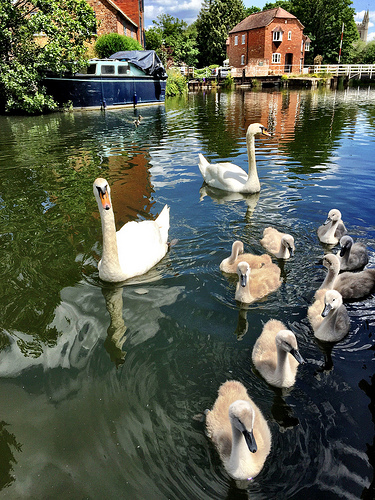<image>
Is there a boat to the right of the duck? No. The boat is not to the right of the duck. The horizontal positioning shows a different relationship. Is the geese next to the water? No. The geese is not positioned next to the water. They are located in different areas of the scene. 